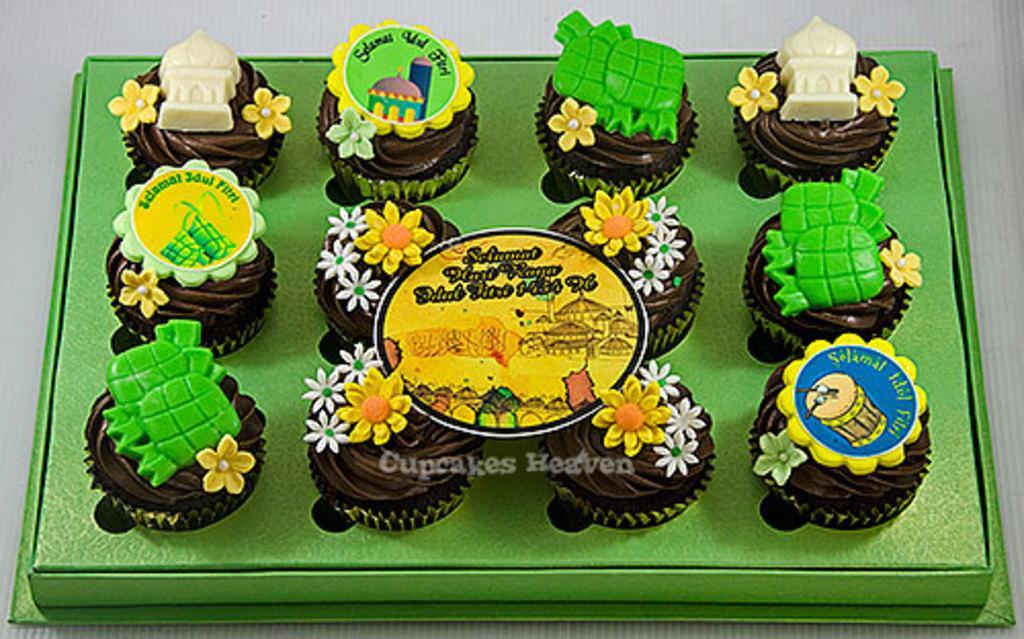In one or two sentences, can you explain what this image depicts? In this picture I see number of cup cakes on which there are few things and these cupcakes are on the green color thing and I see that it is white in the background. 